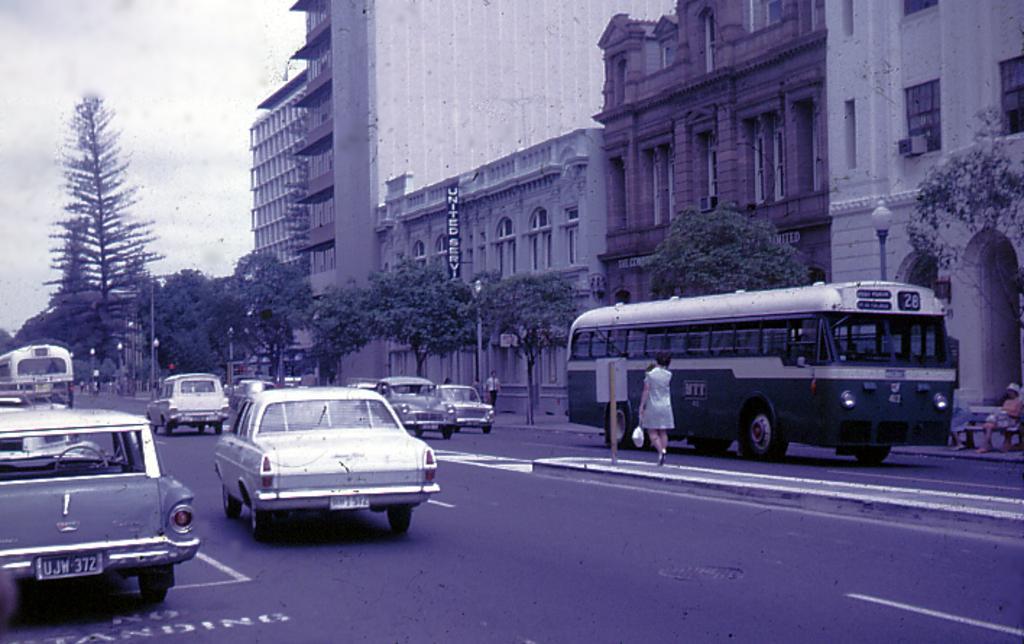Can you describe this image briefly? In this image I can see road. On the road there are vehicles. To the side of the road I can see few people, poles and trees. In the background I can see the building with windows and the sky. 